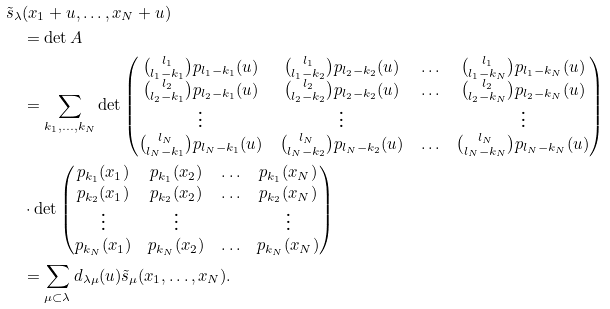<formula> <loc_0><loc_0><loc_500><loc_500>& \tilde { s } _ { \lambda } ( x _ { 1 } + u , \dots , x _ { N } + u ) \\ & \quad = \det A \\ & \quad = \sum _ { k _ { 1 } , \dots , k _ { N } } \det \begin{pmatrix} { l _ { 1 } \choose l _ { 1 } - k _ { 1 } } p _ { l _ { 1 } - k _ { 1 } } ( u ) & { l _ { 1 } \choose l _ { 1 } - k _ { 2 } } p _ { l _ { 2 } - k _ { 2 } } ( u ) & \hdots & { l _ { 1 } \choose l _ { 1 } - k _ { N } } p _ { l _ { 1 } - k _ { N } } ( u ) \\ { l _ { 2 } \choose l _ { 2 } - k _ { 1 } } p _ { l _ { 2 } - k _ { 1 } } ( u ) & { l _ { 2 } \choose l _ { 2 } - k _ { 2 } } p _ { l _ { 2 } - k _ { 2 } } ( u ) & \hdots & { l _ { 2 } \choose l _ { 2 } - k _ { N } } p _ { l _ { 2 } - k _ { N } } ( u ) \\ \vdots & \vdots & & \vdots \\ { l _ { N } \choose l _ { N } - k _ { 1 } } p _ { l _ { N } - k _ { 1 } } ( u ) & { l _ { N } \choose l _ { N } - k _ { 2 } } p _ { l _ { N } - k _ { 2 } } ( u ) & \hdots & { l _ { N } \choose l _ { N } - k _ { N } } p _ { l _ { N } - k _ { N } } ( u ) \\ \end{pmatrix} \\ & \quad \cdot \det \begin{pmatrix} p _ { k _ { 1 } } ( x _ { 1 } ) & p _ { k _ { 1 } } ( x _ { 2 } ) & \hdots & p _ { k _ { 1 } } ( x _ { N } ) \\ p _ { k _ { 2 } } ( x _ { 1 } ) & p _ { k _ { 2 } } ( x _ { 2 } ) & \hdots & p _ { k _ { 2 } } ( x _ { N } ) \\ \vdots & \vdots & & \vdots \\ p _ { k _ { N } } ( x _ { 1 } ) & p _ { k _ { N } } ( x _ { 2 } ) & \hdots & p _ { k _ { N } } ( x _ { N } ) \end{pmatrix} \\ & \quad = \sum _ { \mu \subset \lambda } d _ { \lambda \mu } ( u ) \tilde { s } _ { \mu } ( x _ { 1 } , \dots , x _ { N } ) .</formula> 